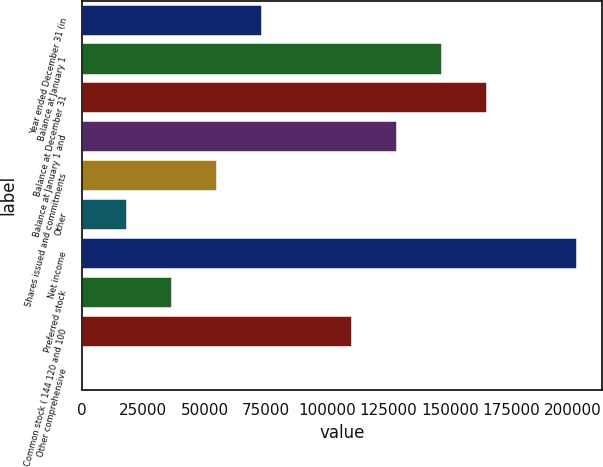<chart> <loc_0><loc_0><loc_500><loc_500><bar_chart><fcel>Year ended December 31 (in<fcel>Balance at January 1<fcel>Balance at December 31<fcel>Balance at January 1 and<fcel>Shares issued and commitments<fcel>Other<fcel>Net income<fcel>Preferred stock<fcel>Common stock ( 144 120 and 100<fcel>Other comprehensive<nl><fcel>73463.4<fcel>146870<fcel>165221<fcel>128518<fcel>55111.8<fcel>18408.6<fcel>201925<fcel>36760.2<fcel>110167<fcel>57<nl></chart> 